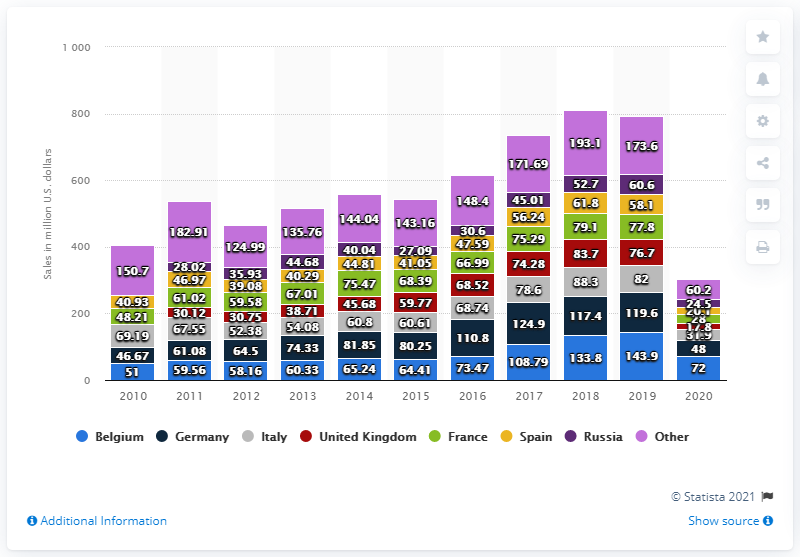Draw attention to some important aspects in this diagram. In 2020, the net sales of Samsonite in Germany were 48 million. 